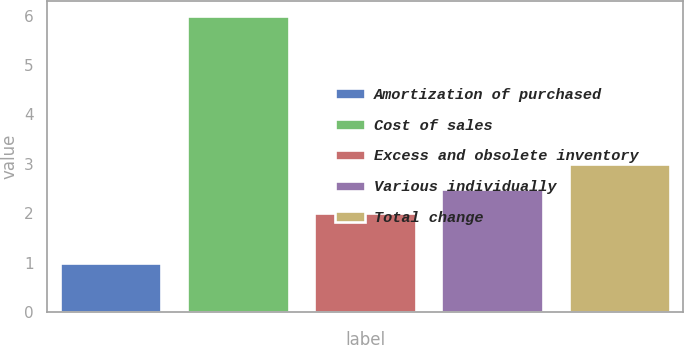<chart> <loc_0><loc_0><loc_500><loc_500><bar_chart><fcel>Amortization of purchased<fcel>Cost of sales<fcel>Excess and obsolete inventory<fcel>Various individually<fcel>Total change<nl><fcel>1<fcel>6<fcel>2<fcel>2.5<fcel>3<nl></chart> 